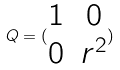<formula> <loc_0><loc_0><loc_500><loc_500>Q = ( \begin{matrix} 1 & 0 \\ 0 & r ^ { 2 } \end{matrix} )</formula> 